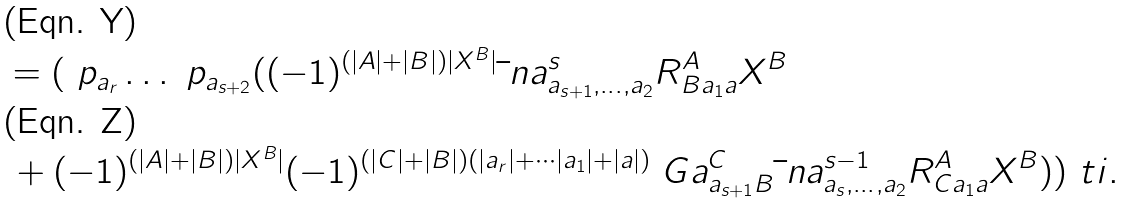<formula> <loc_0><loc_0><loc_500><loc_500>& = ( \ p _ { a _ { r } } \dots \ p _ { a _ { s + 2 } } ( ( - 1 ) ^ { ( | A | + | B | ) | X ^ { B } | } \bar { \ } n a ^ { s } _ { a _ { s + 1 } , \dots , a _ { 2 } } R ^ { A } _ { B a _ { 1 } a } X ^ { B } \\ & \, + ( - 1 ) ^ { ( | A | + | B | ) | X ^ { B } | } ( - 1 ) ^ { ( | C | + | B | ) ( | a _ { r } | + \cdots | a _ { 1 } | + | a | ) } \ G a ^ { C } _ { a _ { s + 1 } B } \bar { \ } n a ^ { s - 1 } _ { a _ { s } , \dots , a _ { 2 } } R ^ { A } _ { C a _ { 1 } a } X ^ { B } ) ) ^ { \ } t i .</formula> 